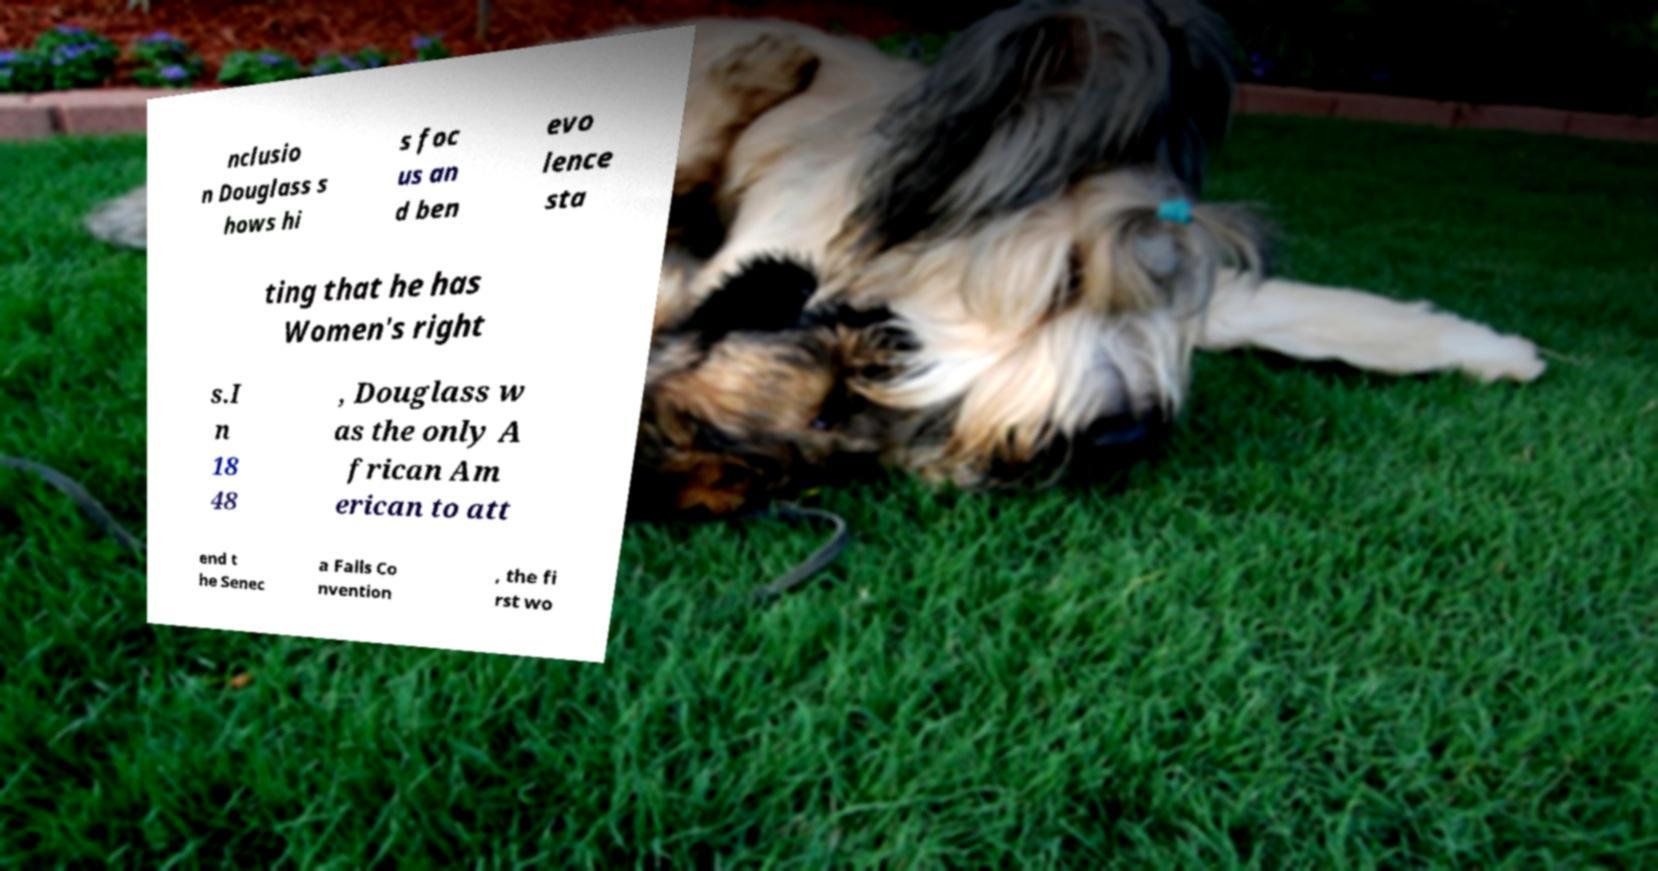Could you extract and type out the text from this image? nclusio n Douglass s hows hi s foc us an d ben evo lence sta ting that he has Women's right s.I n 18 48 , Douglass w as the only A frican Am erican to att end t he Senec a Falls Co nvention , the fi rst wo 